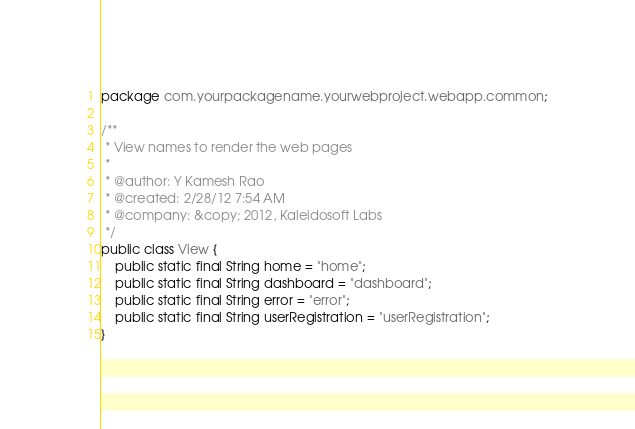Convert code to text. <code><loc_0><loc_0><loc_500><loc_500><_Java_>package com.yourpackagename.yourwebproject.webapp.common;

/**
 * View names to render the web pages
 *
 * @author: Y Kamesh Rao
 * @created: 2/28/12 7:54 AM
 * @company: &copy; 2012, Kaleidosoft Labs
 */
public class View {
    public static final String home = "home";
    public static final String dashboard = "dashboard";
    public static final String error = "error";
    public static final String userRegistration = "userRegistration";
}
</code> 